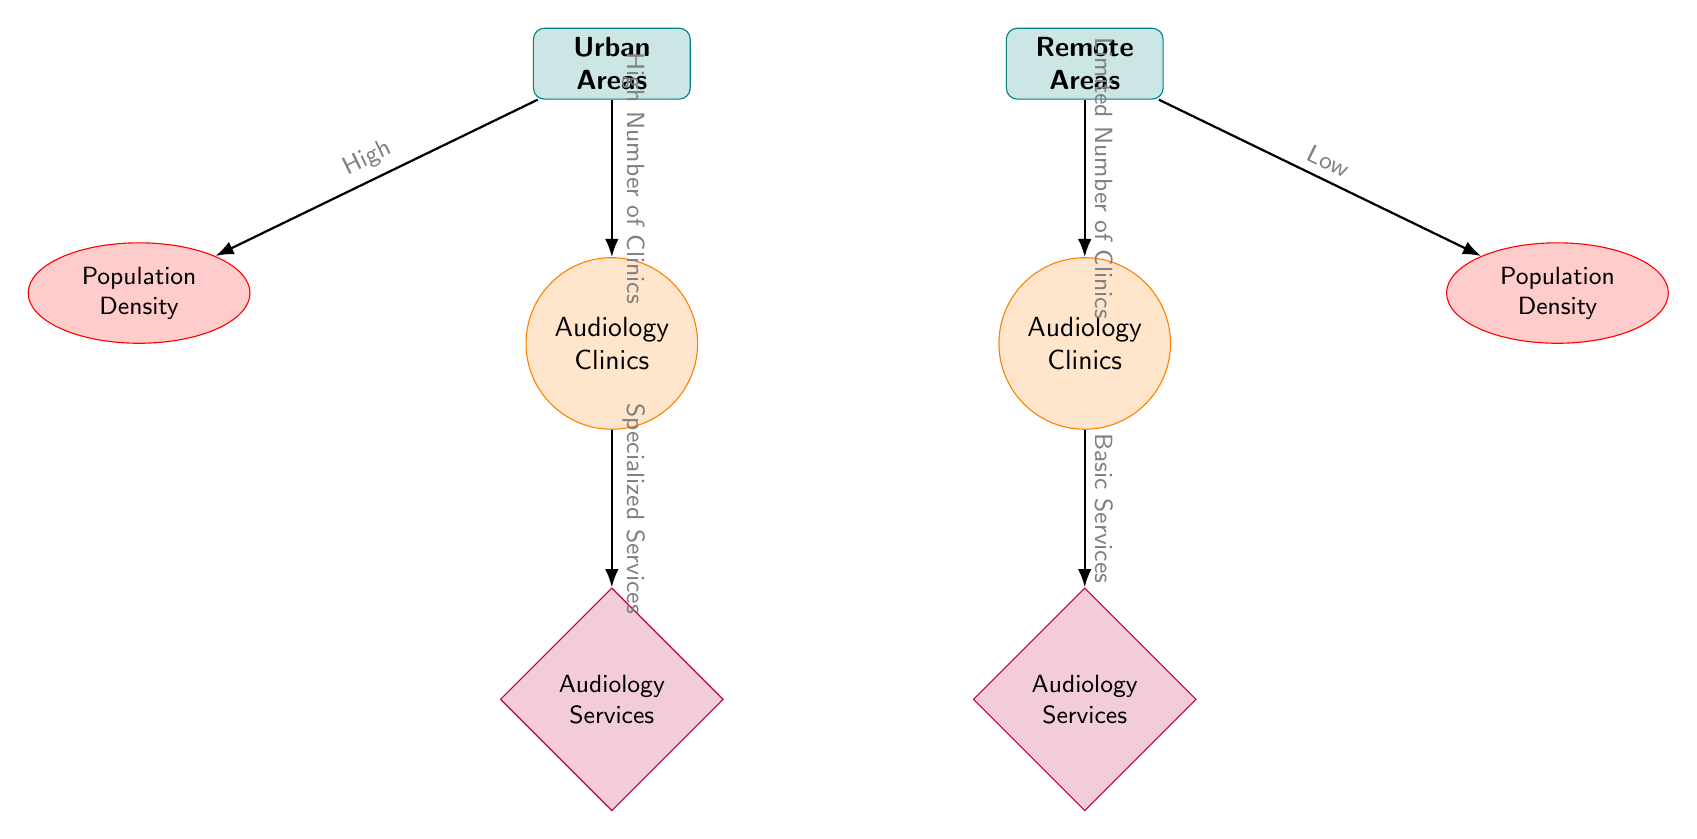What is the population density in urban areas? The diagram depicts urban areas having high population density, represented by the node labeled "Population Density" connected to "Urban Areas."
Answer: High How many types of clinics are indicated in the diagram? The diagram shows two types of clinics, one for urban areas and one for remote areas, represented by the nodes labeled "Audiology Clinics."
Answer: 2 What services are provided by urban clinics? The arrow from the "Audiology Clinics" in urban areas leads to "Audiology Services," indicating the specialized services provided in urban clinics.
Answer: Specialized Services What does the diagram indicate about the clinic availability in remote areas? The arrow from "Remote Areas" points to "Audiology Clinics" with the label "Limited Number of Clinics," indicating fewer clinics are available in remote areas.
Answer: Limited Number of Clinics Which clinic type has access to basic services? The label leading to "Audiology Services" from "Audiology Clinics" in remote areas indicates that these clinics provide basic services.
Answer: Basic Services What is the relationship between clinics and services in urban areas? The diagram shows an edge from "Audiology Clinics" in urban areas to "Audiology Services," indicating there is a direct link where Audiology Clinics provide Audiology Services.
Answer: Specialized Services What do the two populations (urban vs. remote) signify in the diagram? The diagram contrasts "Population Density" in urban areas as high and in remote areas as low, indicating health care resource disparity based on population size and distribution.
Answer: Health Care Disparity How does the availability of services in remote clinics compare to urban clinics? The connections in the diagram show that urban clinics provide specialized services while remote clinics provide basic services, highlighting a difference in service quality available.
Answer: Lower Quality of Services What type of connection illustrates the availability of audiology clinics in remote areas? The connection from "Remote Areas" to "Audiology Clinics" with the label "Limited Number of Clinics" highlights that the link indicates availability constraints.
Answer: Limited Availability 